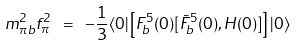<formula> <loc_0><loc_0><loc_500><loc_500>m ^ { 2 } _ { \pi b } f ^ { 2 } _ { \pi } \ = \ - \frac { 1 } { 3 } \langle 0 | \left [ F ^ { 5 } _ { b } ( 0 ) [ \bar { F } ^ { 5 } _ { b } ( 0 ) , H ( 0 ) ] \right ] | 0 \rangle</formula> 